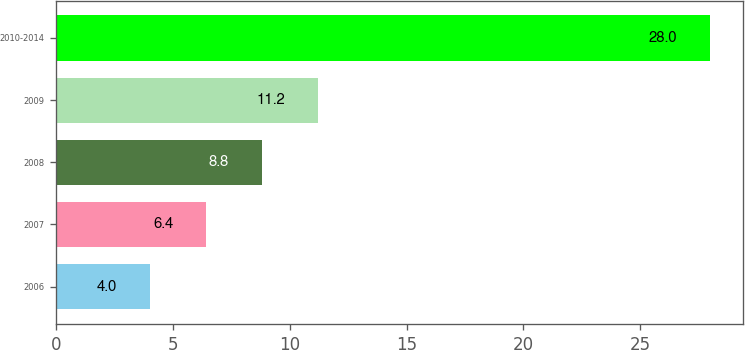Convert chart to OTSL. <chart><loc_0><loc_0><loc_500><loc_500><bar_chart><fcel>2006<fcel>2007<fcel>2008<fcel>2009<fcel>2010-2014<nl><fcel>4<fcel>6.4<fcel>8.8<fcel>11.2<fcel>28<nl></chart> 